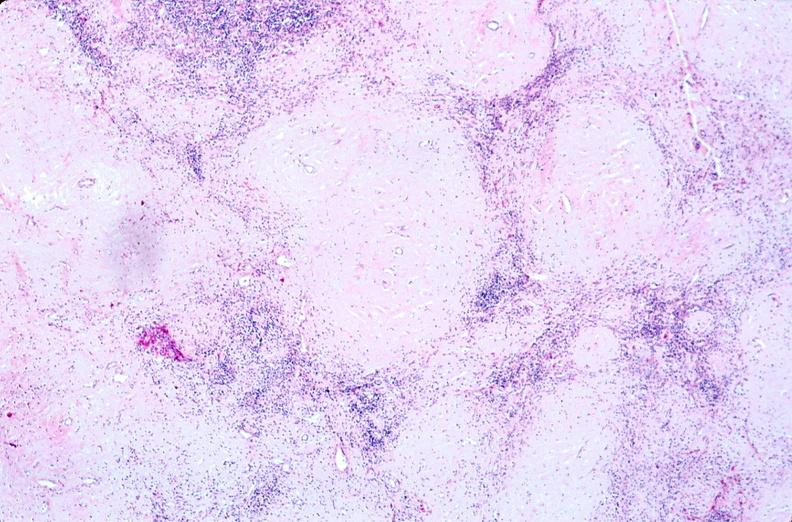what does this image show?
Answer the question using a single word or phrase. Lymph nodes 